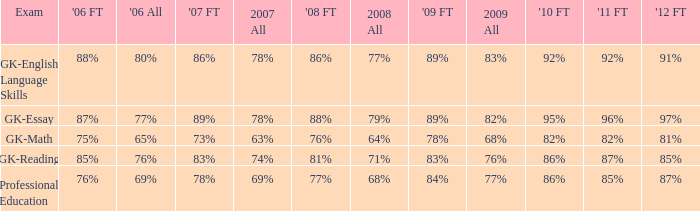What is the percentage for all 2008 when all in 2007 is 69%? 68%. 